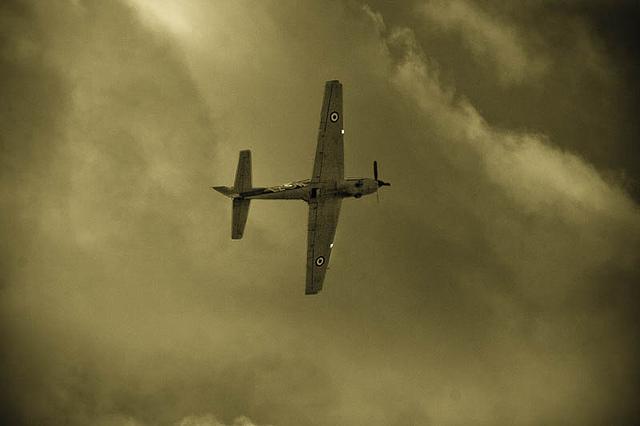Is the picture in color?
Short answer required. No. Can you see any birds flying in the propeller?
Give a very brief answer. No. What type of plane is this?
Short answer required. Fighter. 